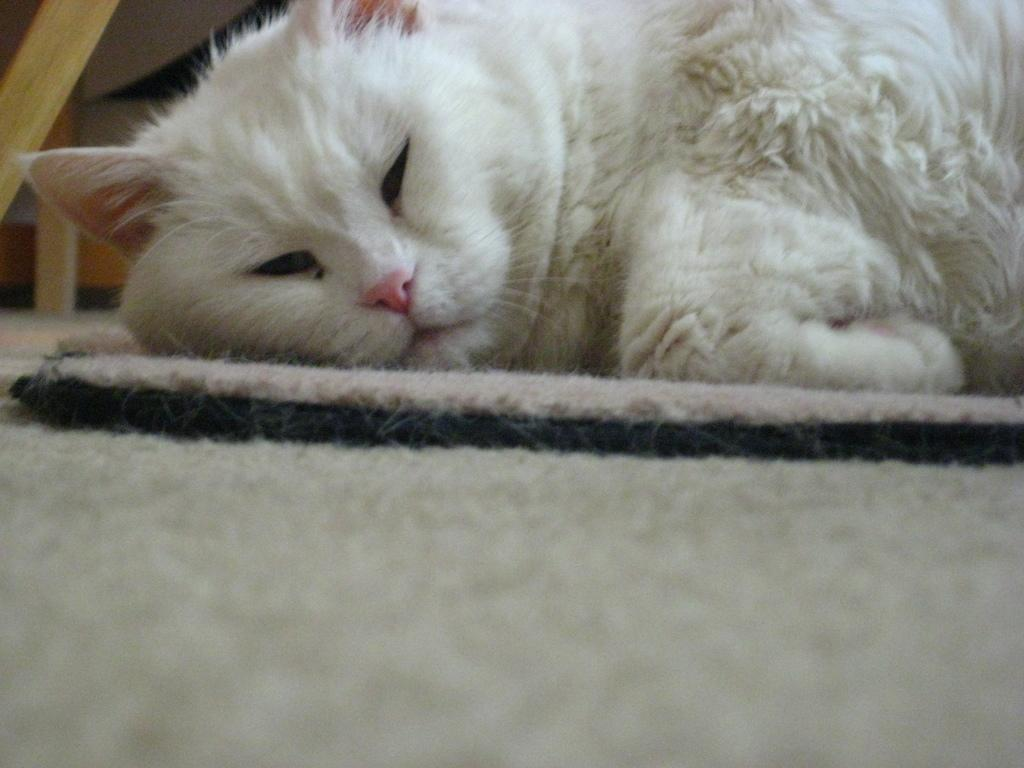What type of animal is in the image? There is a white cat in the image. What is the cat doing in the image? The cat is laying on a mat. Can you see any goldfish swimming in the image? There are no goldfish present in the image; it features a white cat laying on a mat. Is there a door visible in the image? There is no door visible in the image; it only shows a white cat laying on a mat. 